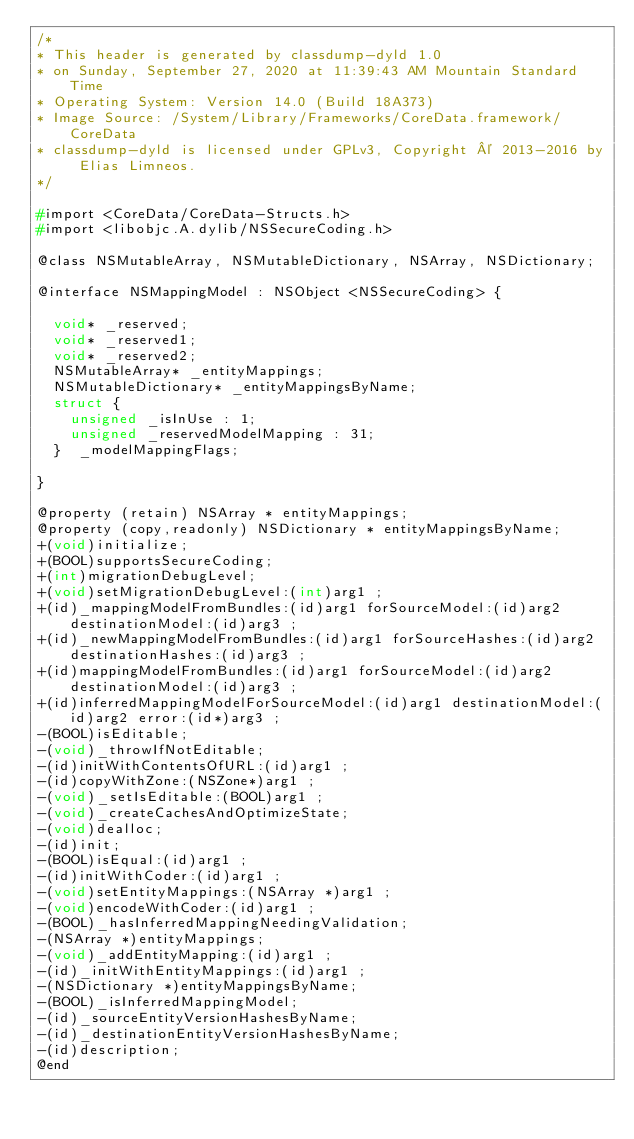<code> <loc_0><loc_0><loc_500><loc_500><_C_>/*
* This header is generated by classdump-dyld 1.0
* on Sunday, September 27, 2020 at 11:39:43 AM Mountain Standard Time
* Operating System: Version 14.0 (Build 18A373)
* Image Source: /System/Library/Frameworks/CoreData.framework/CoreData
* classdump-dyld is licensed under GPLv3, Copyright © 2013-2016 by Elias Limneos.
*/

#import <CoreData/CoreData-Structs.h>
#import <libobjc.A.dylib/NSSecureCoding.h>

@class NSMutableArray, NSMutableDictionary, NSArray, NSDictionary;

@interface NSMappingModel : NSObject <NSSecureCoding> {

	void* _reserved;
	void* _reserved1;
	void* _reserved2;
	NSMutableArray* _entityMappings;
	NSMutableDictionary* _entityMappingsByName;
	struct {
		unsigned _isInUse : 1;
		unsigned _reservedModelMapping : 31;
	}  _modelMappingFlags;

}

@property (retain) NSArray * entityMappings; 
@property (copy,readonly) NSDictionary * entityMappingsByName; 
+(void)initialize;
+(BOOL)supportsSecureCoding;
+(int)migrationDebugLevel;
+(void)setMigrationDebugLevel:(int)arg1 ;
+(id)_mappingModelFromBundles:(id)arg1 forSourceModel:(id)arg2 destinationModel:(id)arg3 ;
+(id)_newMappingModelFromBundles:(id)arg1 forSourceHashes:(id)arg2 destinationHashes:(id)arg3 ;
+(id)mappingModelFromBundles:(id)arg1 forSourceModel:(id)arg2 destinationModel:(id)arg3 ;
+(id)inferredMappingModelForSourceModel:(id)arg1 destinationModel:(id)arg2 error:(id*)arg3 ;
-(BOOL)isEditable;
-(void)_throwIfNotEditable;
-(id)initWithContentsOfURL:(id)arg1 ;
-(id)copyWithZone:(NSZone*)arg1 ;
-(void)_setIsEditable:(BOOL)arg1 ;
-(void)_createCachesAndOptimizeState;
-(void)dealloc;
-(id)init;
-(BOOL)isEqual:(id)arg1 ;
-(id)initWithCoder:(id)arg1 ;
-(void)setEntityMappings:(NSArray *)arg1 ;
-(void)encodeWithCoder:(id)arg1 ;
-(BOOL)_hasInferredMappingNeedingValidation;
-(NSArray *)entityMappings;
-(void)_addEntityMapping:(id)arg1 ;
-(id)_initWithEntityMappings:(id)arg1 ;
-(NSDictionary *)entityMappingsByName;
-(BOOL)_isInferredMappingModel;
-(id)_sourceEntityVersionHashesByName;
-(id)_destinationEntityVersionHashesByName;
-(id)description;
@end

</code> 